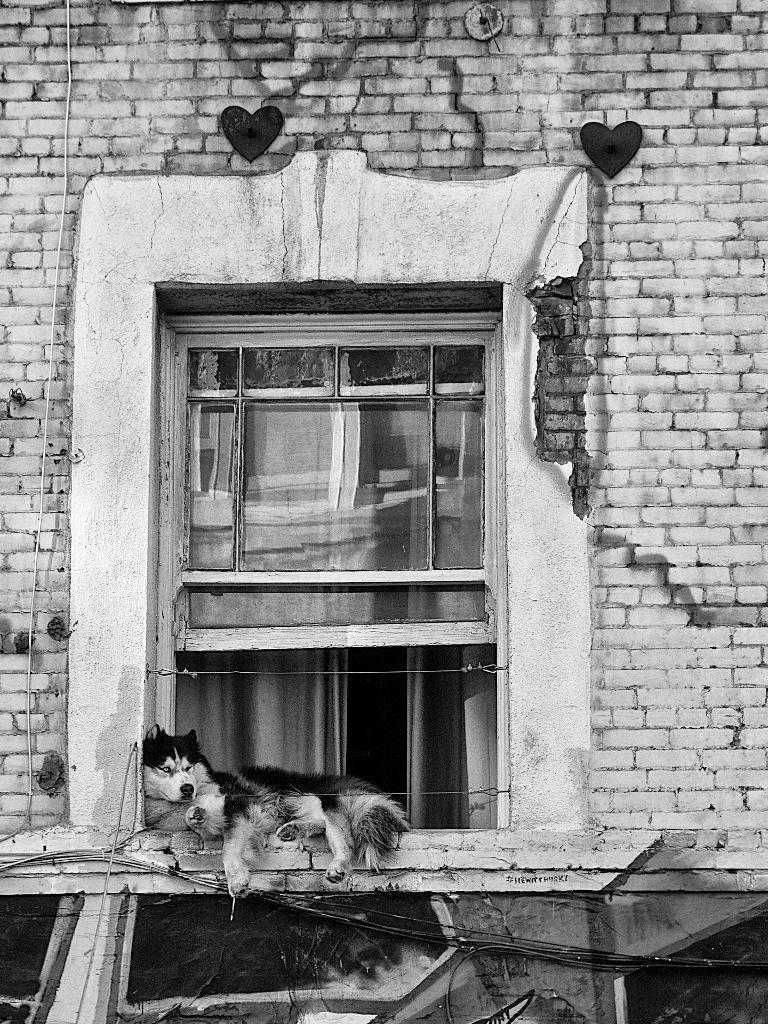What is the color scheme of the image? The image is black and white. What structure can be seen in the image? There is a building in the image. Does the building have any specific features? Yes, the building has a window. What animal is present in the image? There is a dog lying on a wall in the image. Who is the writer in the image? There is no writer present in the image. What group of people can be seen reading in the image? There are no people reading in the image; it only features a building, a window, and a dog lying on a wall. 